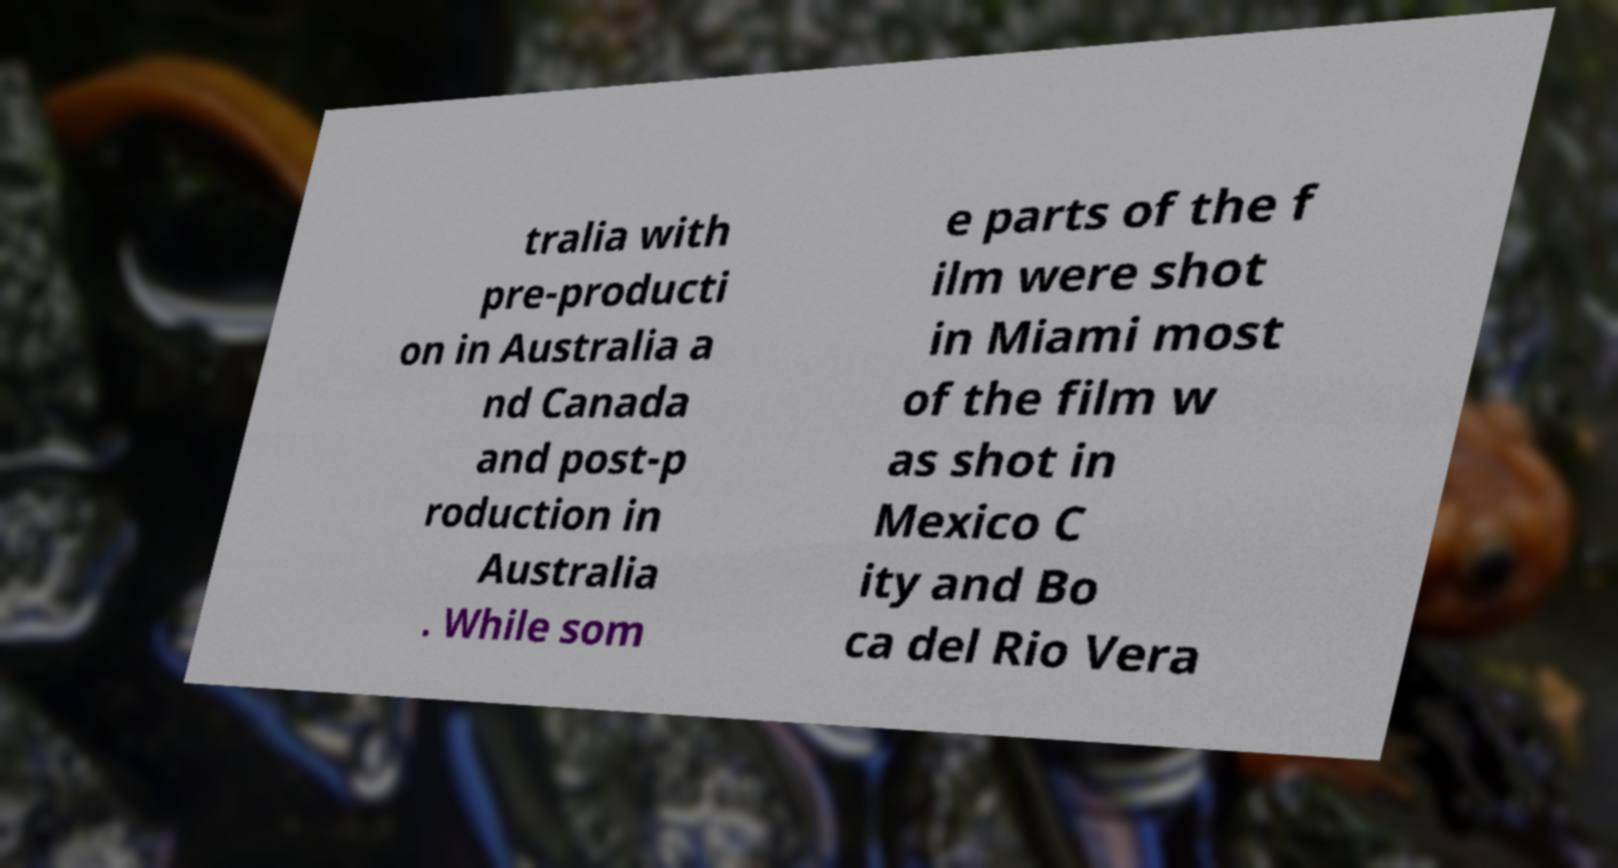Can you accurately transcribe the text from the provided image for me? tralia with pre-producti on in Australia a nd Canada and post-p roduction in Australia . While som e parts of the f ilm were shot in Miami most of the film w as shot in Mexico C ity and Bo ca del Rio Vera 